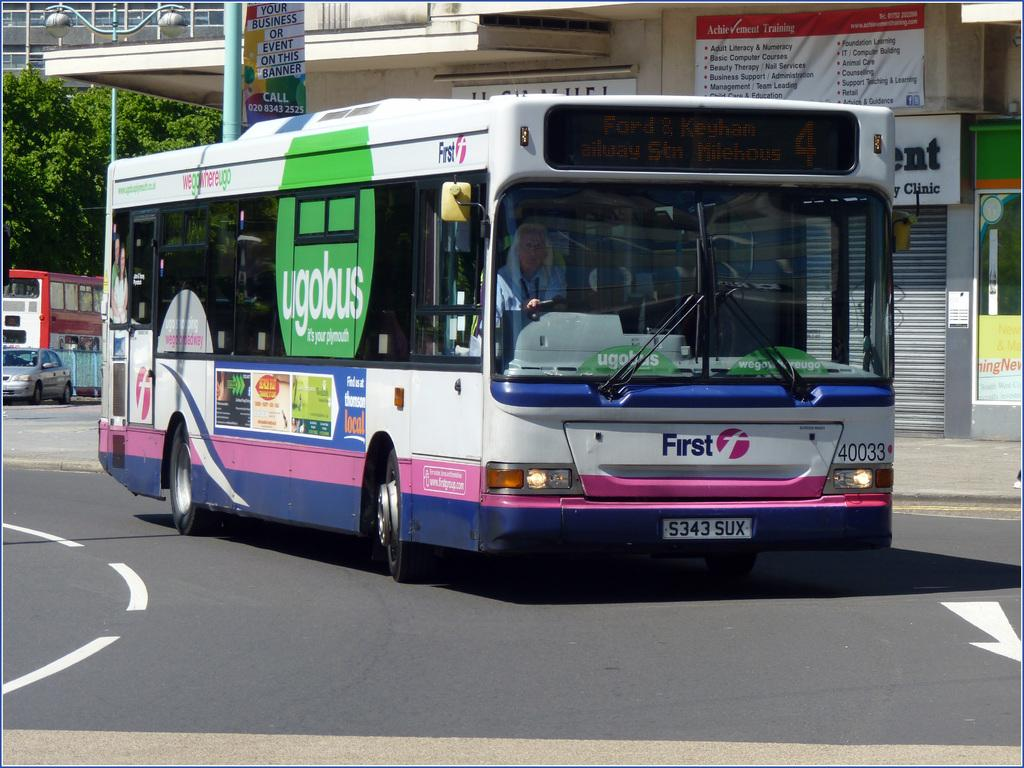<image>
Provide a brief description of the given image. A city bus that says first on the very front driving down a city street. 